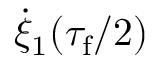Convert formula to latex. <formula><loc_0><loc_0><loc_500><loc_500>\dot { \xi } _ { 1 } ( \tau _ { f } / 2 )</formula> 